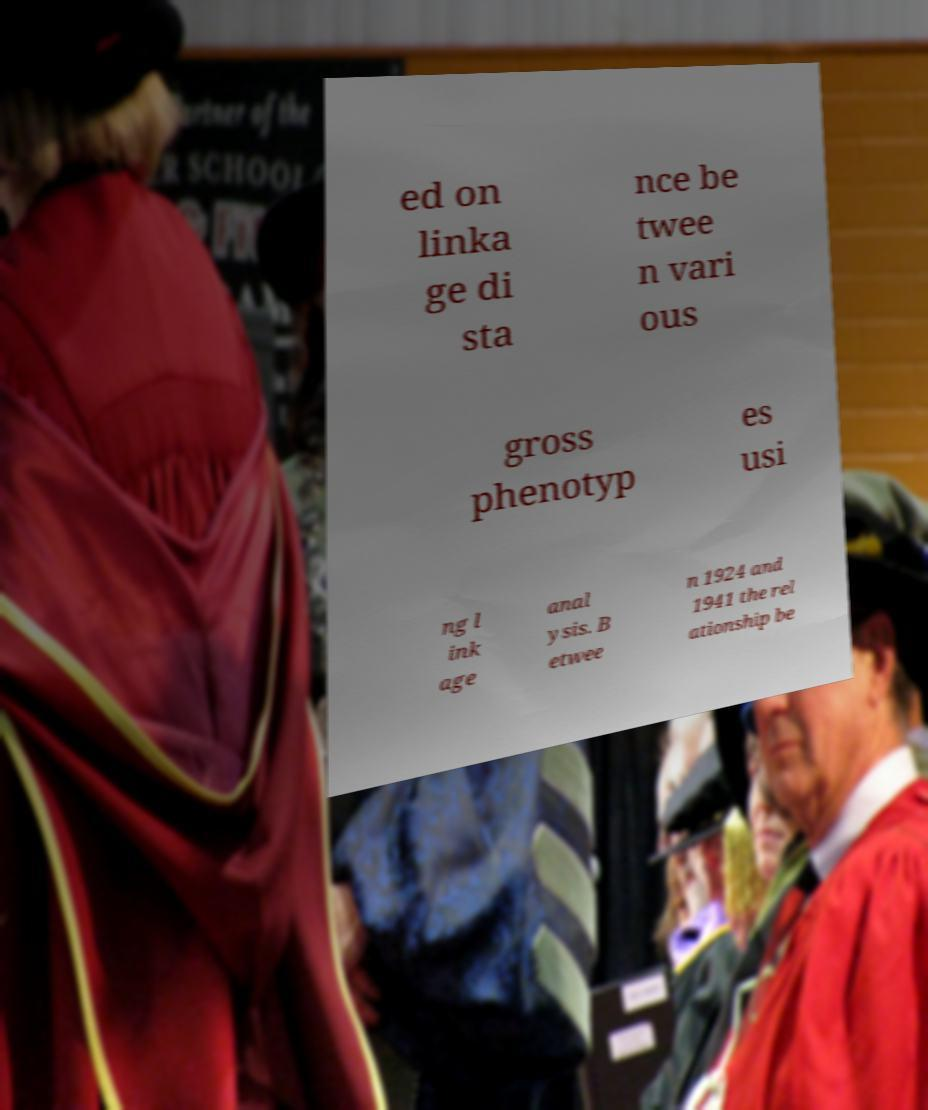Could you extract and type out the text from this image? ed on linka ge di sta nce be twee n vari ous gross phenotyp es usi ng l ink age anal ysis. B etwee n 1924 and 1941 the rel ationship be 